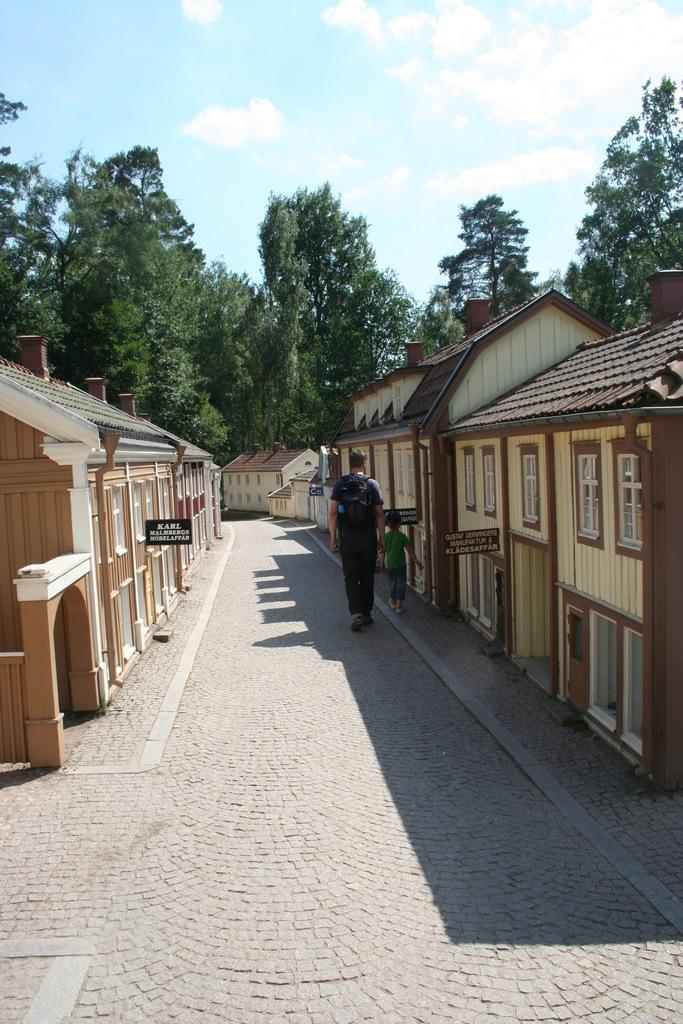What is happening on the road in the image? There are persons on the road in the image. What can be seen on the right side of the image? There are houses on the right side of the image. What can be seen on the left side of the image? There are houses on the left side of the image. What type of vegetation is visible in the background of the image? There are trees in the background of the image. What is visible in the sky in the background of the image? The sky is visible in the background of the image, and there are clouds in the sky. Where is the heart-shaped patch located on the person in the image? There is no person with a heart-shaped patch in the image. What type of view can be seen from the houses in the image? The provided facts do not mention a view from the houses, so it cannot be determined from the image. 